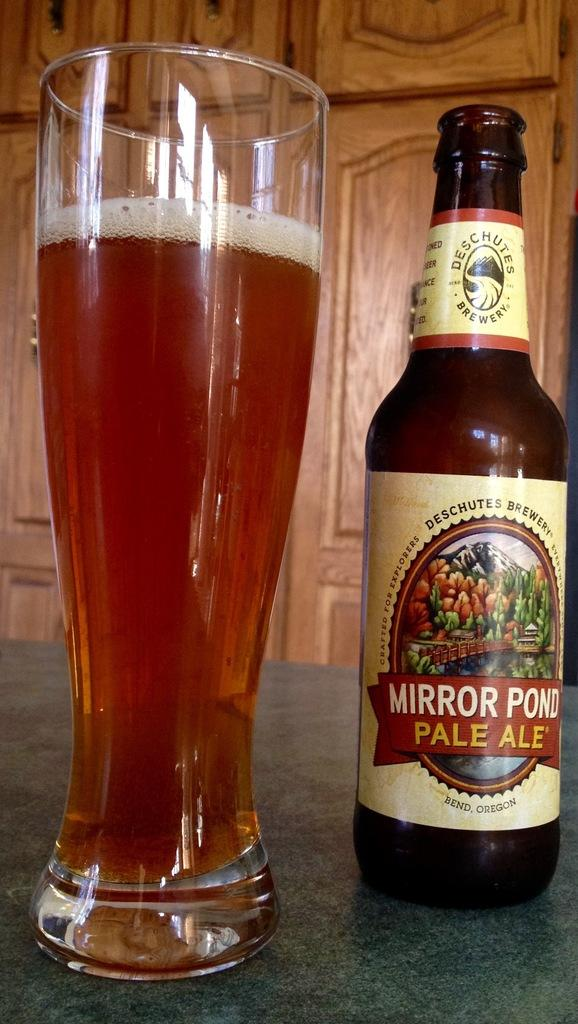Provide a one-sentence caption for the provided image. A bottle of beer is labeled Mirror Pond Pale Ale. 